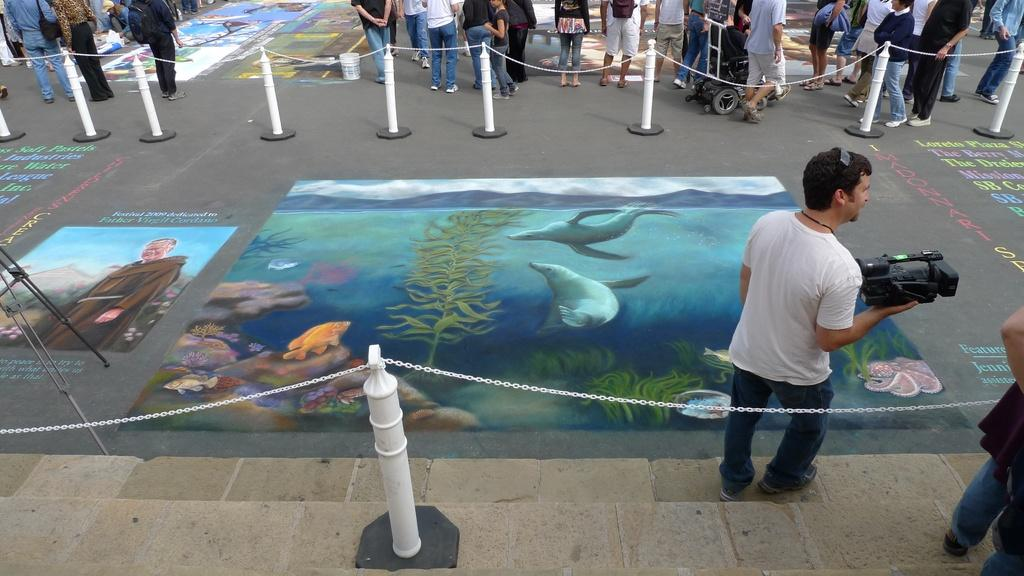What is depicted on the road in the image? There are paintings on the road in the image. What is used to enclose the paintings? There is fencing around the paintings. Are there any people present in the image? Yes, there are people in the image. What might one of the people be doing with a specific device? One person is holding a camera. How many sheep can be seen grazing on the island in the image? There is no island or sheep present in the image. What is the distribution of the paintings in the image? The paintings are depicted on the road in the image, and their distribution cannot be determined without more specific information about their arrangement. 